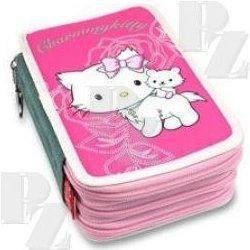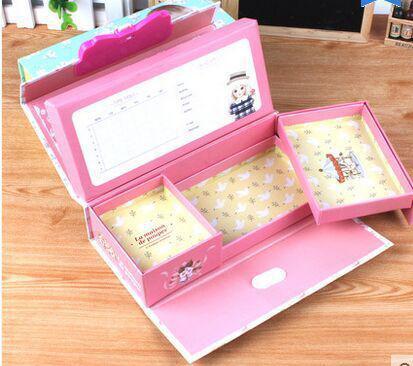The first image is the image on the left, the second image is the image on the right. Given the left and right images, does the statement "At least one of the pencil cases opens and closes with a zipper." hold true? Answer yes or no. Yes. The first image is the image on the left, the second image is the image on the right. Given the left and right images, does the statement "One image shows a closed hard-sided pencil case with a big-eyed cartoon girl on the front, and the other shows an open pink-and-white case." hold true? Answer yes or no. No. 